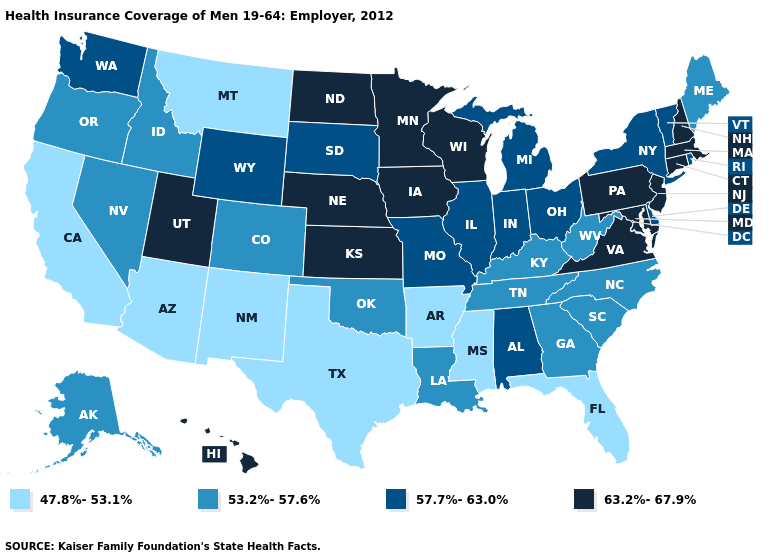Among the states that border California , does Arizona have the highest value?
Concise answer only. No. Does Kentucky have the lowest value in the USA?
Keep it brief. No. What is the lowest value in the USA?
Keep it brief. 47.8%-53.1%. Which states hav the highest value in the Northeast?
Answer briefly. Connecticut, Massachusetts, New Hampshire, New Jersey, Pennsylvania. Which states have the lowest value in the South?
Give a very brief answer. Arkansas, Florida, Mississippi, Texas. Does Idaho have the lowest value in the USA?
Write a very short answer. No. What is the value of Indiana?
Be succinct. 57.7%-63.0%. Does Arkansas have the lowest value in the South?
Quick response, please. Yes. Does Vermont have a lower value than Minnesota?
Quick response, please. Yes. Which states have the highest value in the USA?
Answer briefly. Connecticut, Hawaii, Iowa, Kansas, Maryland, Massachusetts, Minnesota, Nebraska, New Hampshire, New Jersey, North Dakota, Pennsylvania, Utah, Virginia, Wisconsin. How many symbols are there in the legend?
Give a very brief answer. 4. What is the value of Michigan?
Write a very short answer. 57.7%-63.0%. Name the states that have a value in the range 57.7%-63.0%?
Write a very short answer. Alabama, Delaware, Illinois, Indiana, Michigan, Missouri, New York, Ohio, Rhode Island, South Dakota, Vermont, Washington, Wyoming. Does the first symbol in the legend represent the smallest category?
Write a very short answer. Yes. 